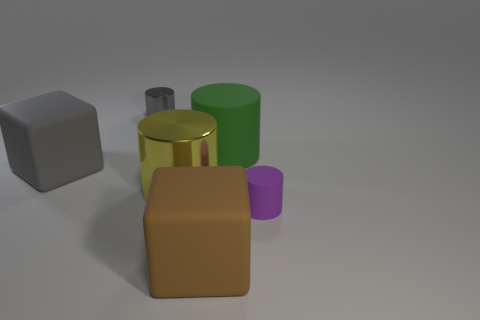Subtract all large green rubber cylinders. How many cylinders are left? 3 Add 3 large matte objects. How many objects exist? 9 Subtract 3 cylinders. How many cylinders are left? 1 Subtract all purple cylinders. How many cylinders are left? 3 Subtract all cylinders. How many objects are left? 2 Add 6 yellow things. How many yellow things are left? 7 Add 6 small green things. How many small green things exist? 6 Subtract 0 purple cubes. How many objects are left? 6 Subtract all gray cylinders. Subtract all gray balls. How many cylinders are left? 3 Subtract all gray cubes. How many green cylinders are left? 1 